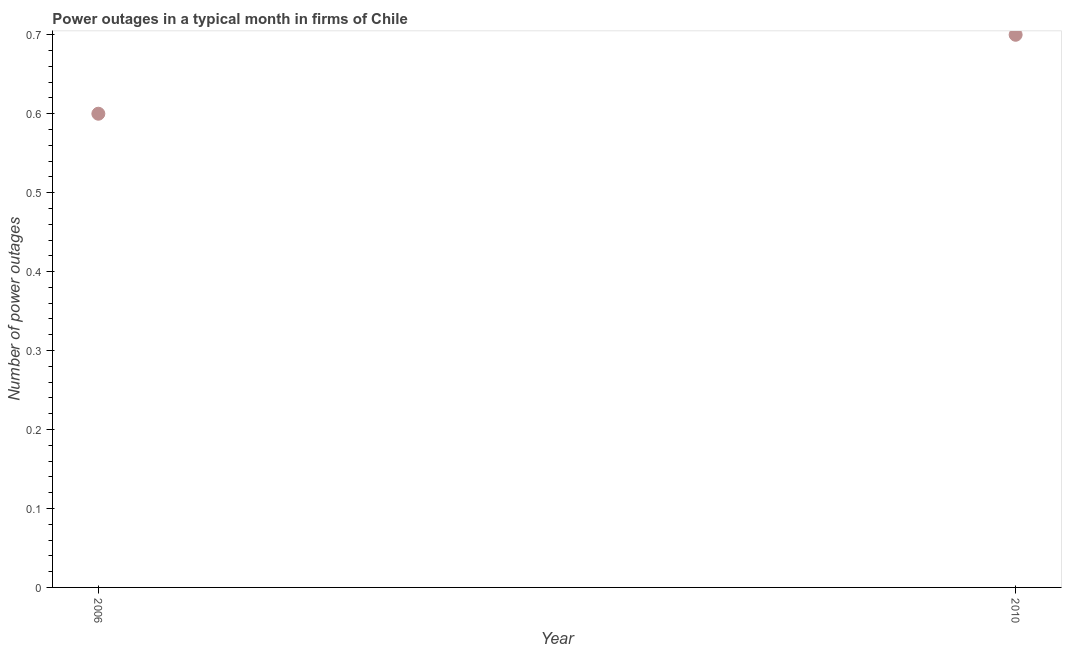Across all years, what is the maximum number of power outages?
Make the answer very short. 0.7. What is the sum of the number of power outages?
Your answer should be very brief. 1.3. What is the difference between the number of power outages in 2006 and 2010?
Your response must be concise. -0.1. What is the average number of power outages per year?
Your response must be concise. 0.65. What is the median number of power outages?
Give a very brief answer. 0.65. In how many years, is the number of power outages greater than 0.6000000000000001 ?
Ensure brevity in your answer.  1. Do a majority of the years between 2006 and 2010 (inclusive) have number of power outages greater than 0.2 ?
Your answer should be compact. Yes. What is the ratio of the number of power outages in 2006 to that in 2010?
Ensure brevity in your answer.  0.86. In how many years, is the number of power outages greater than the average number of power outages taken over all years?
Provide a succinct answer. 1. How many dotlines are there?
Keep it short and to the point. 1. Does the graph contain grids?
Make the answer very short. No. What is the title of the graph?
Offer a terse response. Power outages in a typical month in firms of Chile. What is the label or title of the Y-axis?
Give a very brief answer. Number of power outages. What is the Number of power outages in 2006?
Provide a succinct answer. 0.6. What is the ratio of the Number of power outages in 2006 to that in 2010?
Offer a terse response. 0.86. 